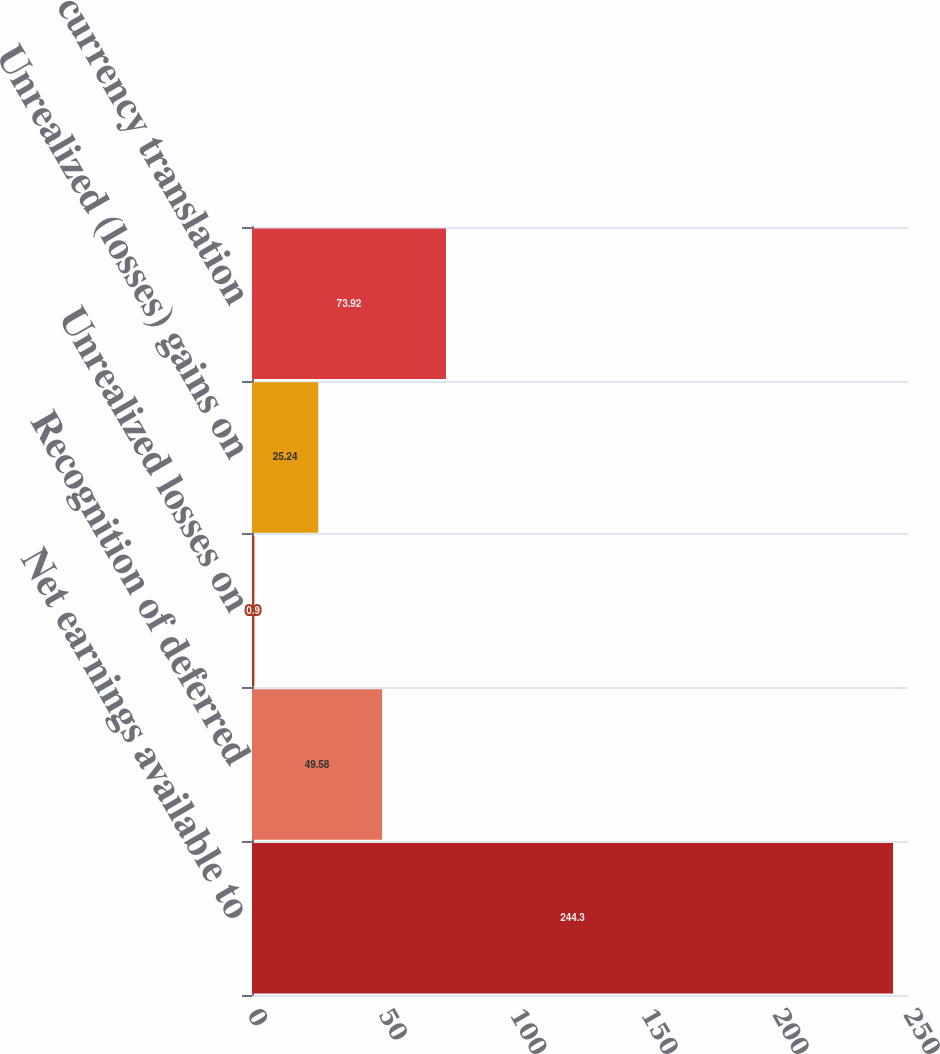<chart> <loc_0><loc_0><loc_500><loc_500><bar_chart><fcel>Net earnings available to<fcel>Recognition of deferred<fcel>Unrealized losses on<fcel>Unrealized (losses) gains on<fcel>Foreign currency translation<nl><fcel>244.3<fcel>49.58<fcel>0.9<fcel>25.24<fcel>73.92<nl></chart> 